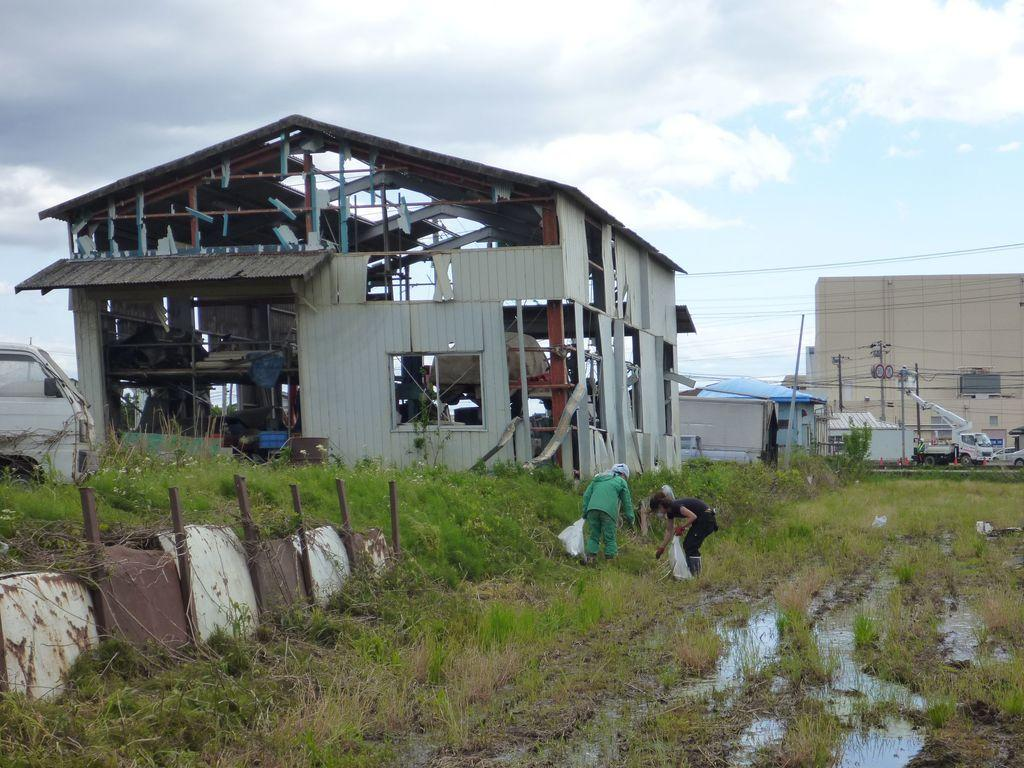Who or what can be seen in the image? There are people in the image. What can be seen in the distance behind the people? There are buildings, poles, vehicles, cables, plants, and clouds visible in the background of the image. What type of library can be seen in the image? There is no library present in the image. Can you provide an example of a connection between the people and the vehicles in the image? There is no need to provide an example of a connection between the people and the vehicles, as the question is based on an assumption that is not present in the image. 